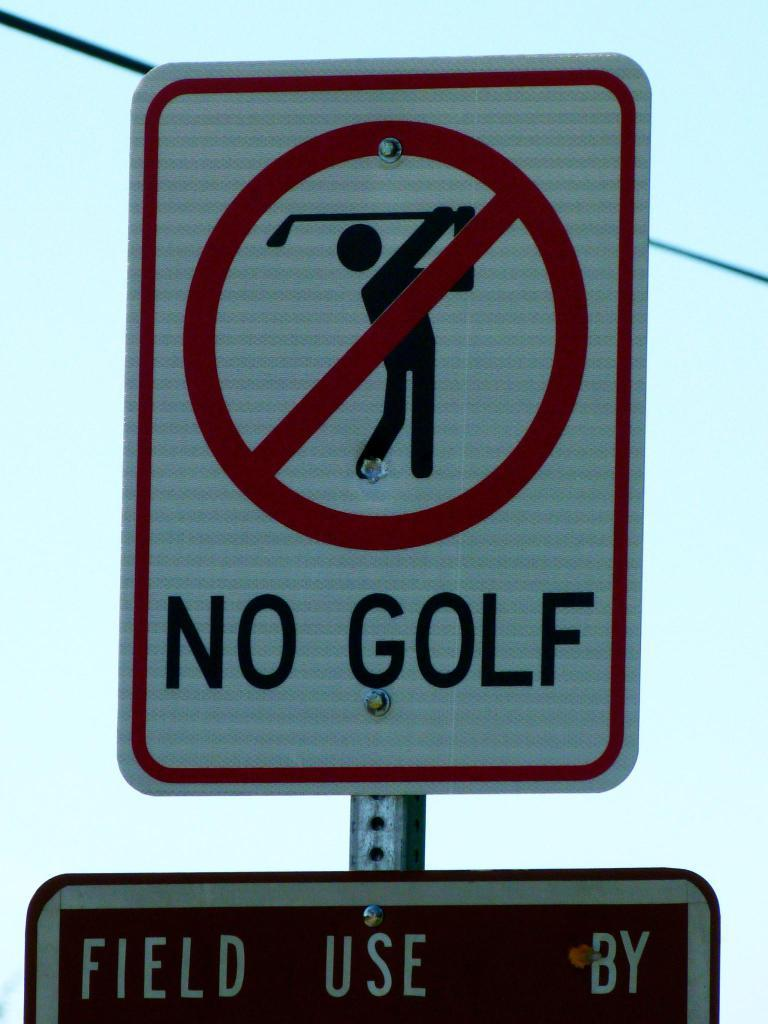Provide a one-sentence caption for the provided image. Red and white street sign that says No Golf. 